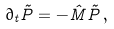<formula> <loc_0><loc_0><loc_500><loc_500>\partial _ { t } \vec { P } = - \hat { M } \vec { P } \, ,</formula> 